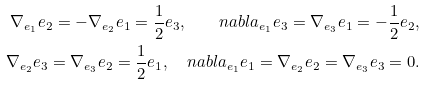<formula> <loc_0><loc_0><loc_500><loc_500>\nabla _ { e _ { 1 } } e _ { 2 } = - \nabla _ { e _ { 2 } } e _ { 1 } = \frac { 1 } { 2 } e _ { 3 } , \quad n a b l a _ { e _ { 1 } } e _ { 3 } = \nabla _ { e _ { 3 } } e _ { 1 } = - \frac { 1 } { 2 } e _ { 2 } , \\ \nabla _ { e _ { 2 } } e _ { 3 } = \nabla _ { e _ { 3 } } e _ { 2 } = \frac { 1 } { 2 } e _ { 1 } , \quad n a b l a _ { e _ { 1 } } e _ { 1 } = \nabla _ { e _ { 2 } } e _ { 2 } = \nabla _ { e _ { 3 } } e _ { 3 } = 0 .</formula> 